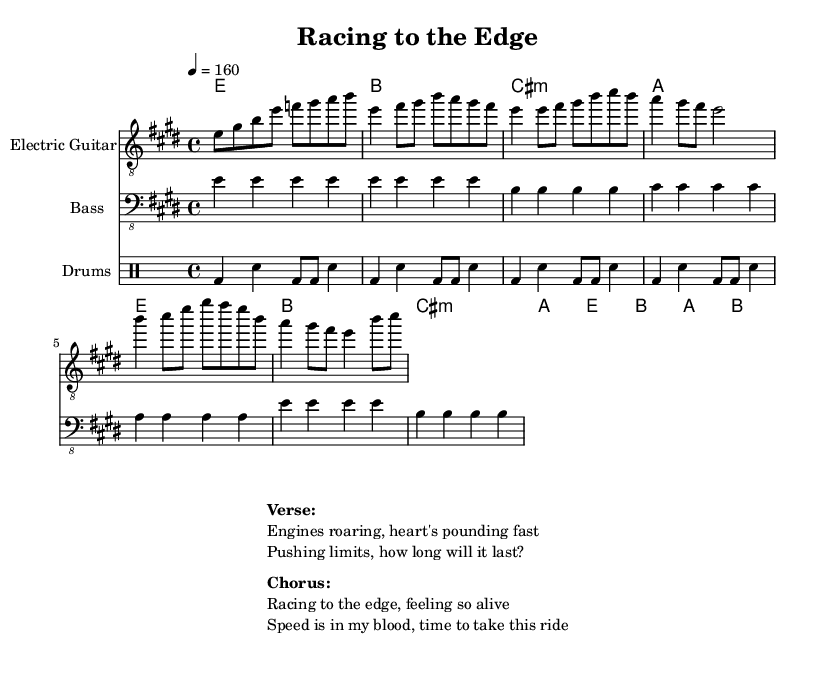What is the key signature of this music? The key signature is E major, which has four sharps (F#, C#, G#, and D#). This is indicated at the beginning of the staff.
Answer: E major What is the time signature of this music? The time signature is 4/4. This means there are four beats in each measure and the quarter note gets one beat. It is visible at the beginning of the sheet music.
Answer: 4/4 What is the tempo of the piece? The tempo is marked at 160 beats per minute, indicated by the "4 = 160" symbol. This tells musicians how fast to play the piece.
Answer: 160 How many measures are in the chorus section? The chorus section consists of four measures. By counting the sections labeled "Chorus" in the sheet music, we can find that there are four distinct measures.
Answer: 4 What instruments are featured in this piece? The instruments included are Electric Guitar, Bass, and Drums. Each part is clearly defined in separate staves within the score.
Answer: Electric Guitar, Bass, Drums What chords are used in the chorus section? The chords used in the chorus are E, B, A, and B. These chords appear in the chord mode section during the chorus part.
Answer: E, B, A, B What is the main theme expressed in the verse lyrics? The verse lyrics express a sense of urgency and thrill related to racing and speed, focusing on excitement and the adrenaline rush. This is conveyed through phrases like "Engines roaring" and "Pushing limits."
Answer: Urgency and thrill 